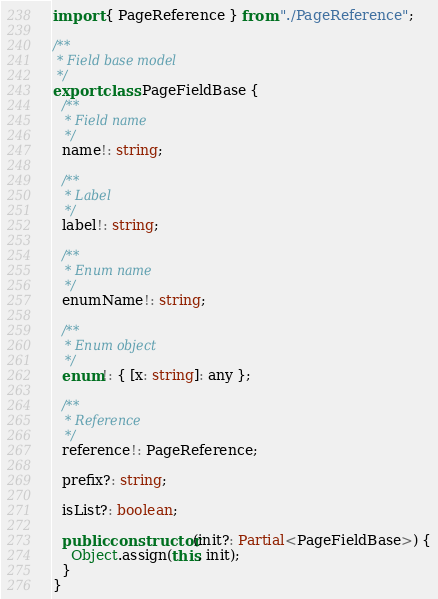<code> <loc_0><loc_0><loc_500><loc_500><_TypeScript_>import { PageReference } from "./PageReference";

/**
 * Field base model
 */
export class PageFieldBase {
  /**
   * Field name
   */
  name!: string;

  /**
   * Label
   */
  label!: string;

  /**
   * Enum name
   */
  enumName!: string;

  /**
   * Enum object
   */
  enum!: { [x: string]: any };

  /**
   * Reference
   */
  reference!: PageReference;

  prefix?: string;

  isList?: boolean;

  public constructor(init?: Partial<PageFieldBase>) {
    Object.assign(this, init);
  }
}
</code> 